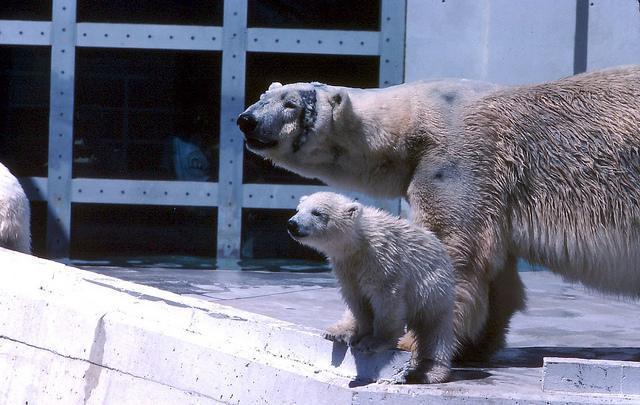How many bears are there?
Give a very brief answer. 3. 